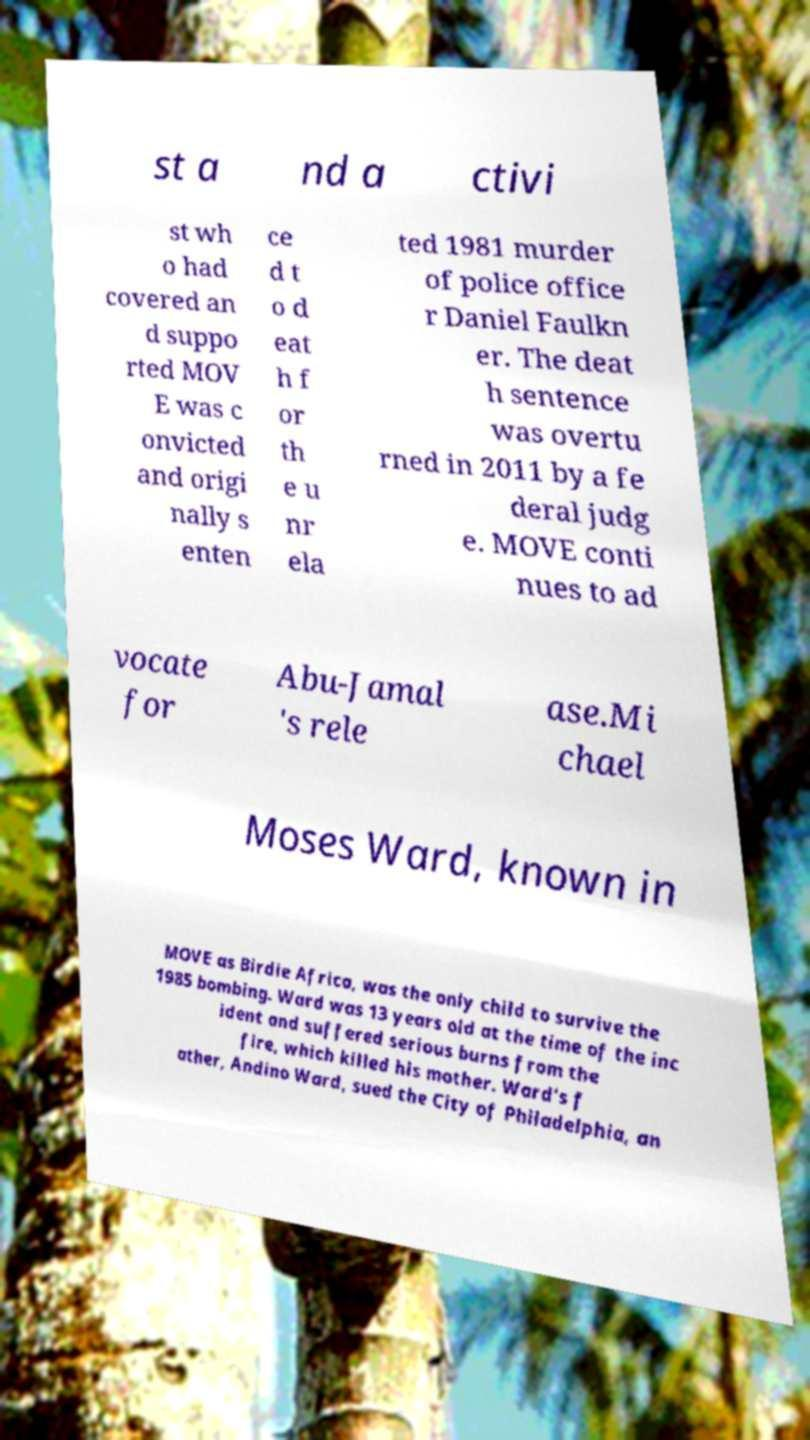Can you read and provide the text displayed in the image?This photo seems to have some interesting text. Can you extract and type it out for me? st a nd a ctivi st wh o had covered an d suppo rted MOV E was c onvicted and origi nally s enten ce d t o d eat h f or th e u nr ela ted 1981 murder of police office r Daniel Faulkn er. The deat h sentence was overtu rned in 2011 by a fe deral judg e. MOVE conti nues to ad vocate for Abu-Jamal 's rele ase.Mi chael Moses Ward, known in MOVE as Birdie Africa, was the only child to survive the 1985 bombing. Ward was 13 years old at the time of the inc ident and suffered serious burns from the fire, which killed his mother. Ward's f ather, Andino Ward, sued the City of Philadelphia, an 